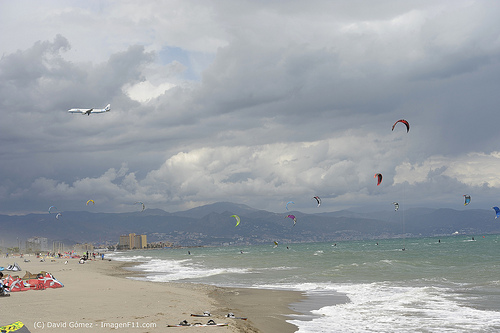Please provide a short description for this region: [0.28, 0.53, 0.55, 0.64]. The region with the bounding box coordinates [0.28, 0.53, 0.55, 0.64] shows a mountain in the background. 